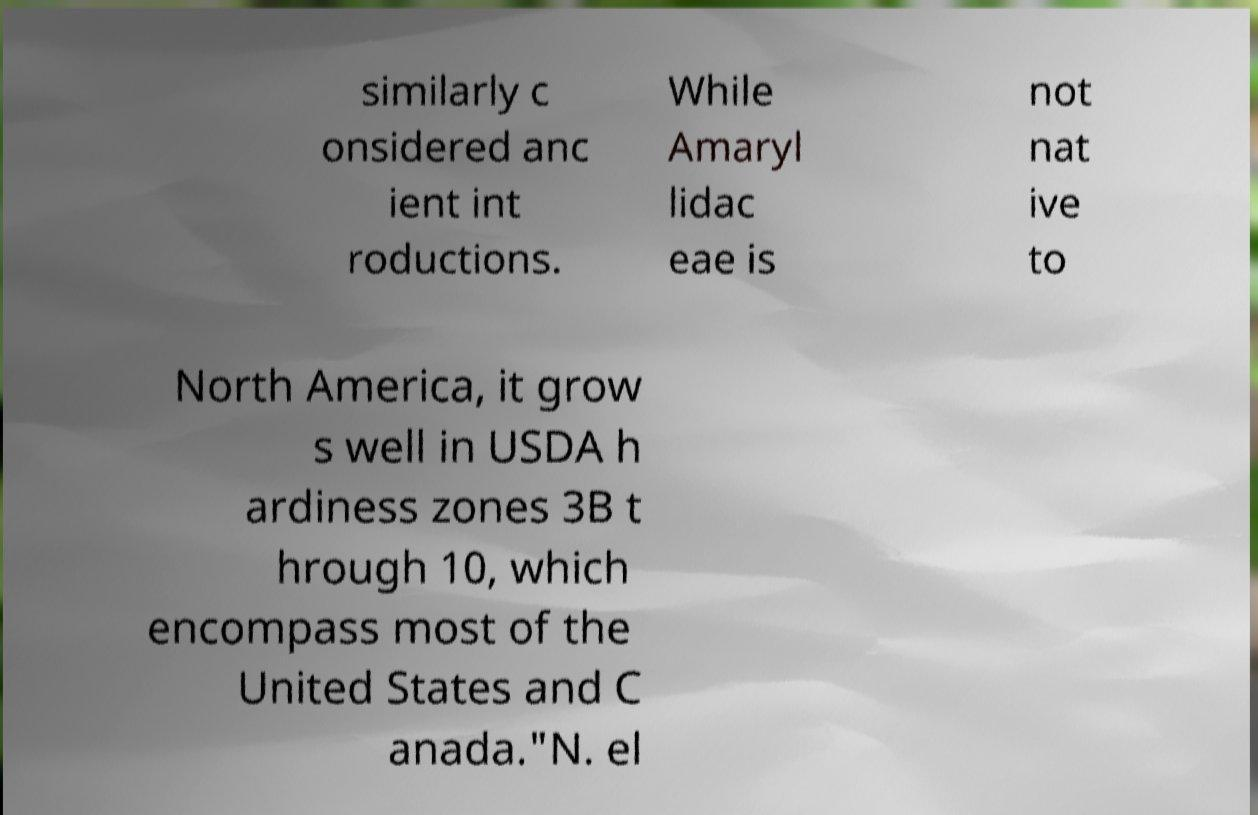Could you assist in decoding the text presented in this image and type it out clearly? similarly c onsidered anc ient int roductions. While Amaryl lidac eae is not nat ive to North America, it grow s well in USDA h ardiness zones 3B t hrough 10, which encompass most of the United States and C anada."N. el 